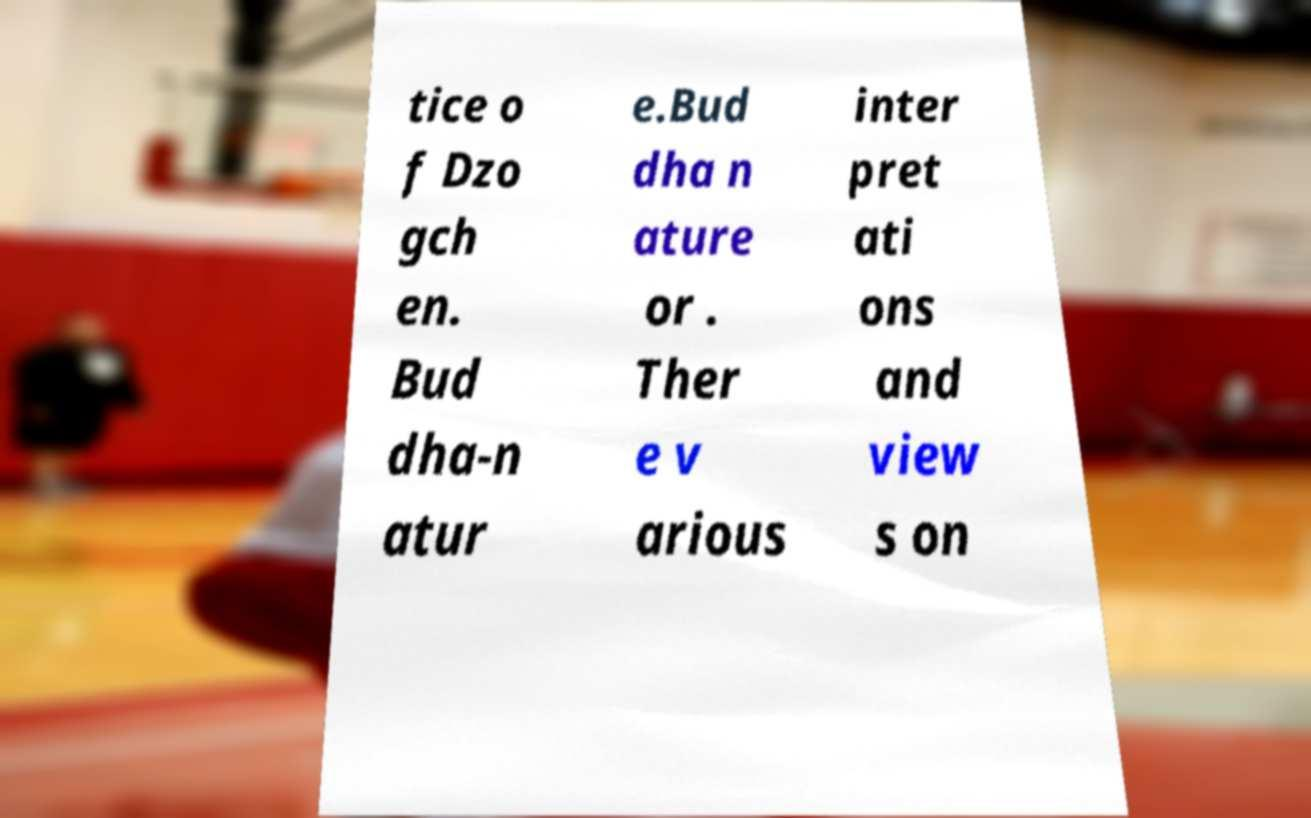Please read and relay the text visible in this image. What does it say? tice o f Dzo gch en. Bud dha-n atur e.Bud dha n ature or . Ther e v arious inter pret ati ons and view s on 